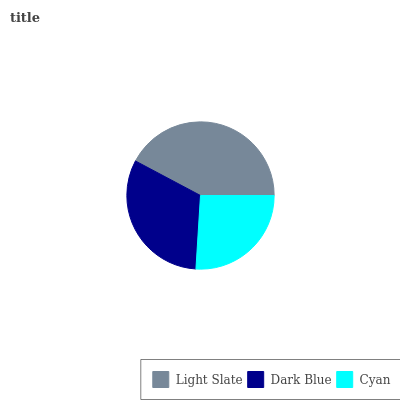Is Cyan the minimum?
Answer yes or no. Yes. Is Light Slate the maximum?
Answer yes or no. Yes. Is Dark Blue the minimum?
Answer yes or no. No. Is Dark Blue the maximum?
Answer yes or no. No. Is Light Slate greater than Dark Blue?
Answer yes or no. Yes. Is Dark Blue less than Light Slate?
Answer yes or no. Yes. Is Dark Blue greater than Light Slate?
Answer yes or no. No. Is Light Slate less than Dark Blue?
Answer yes or no. No. Is Dark Blue the high median?
Answer yes or no. Yes. Is Dark Blue the low median?
Answer yes or no. Yes. Is Light Slate the high median?
Answer yes or no. No. Is Cyan the low median?
Answer yes or no. No. 